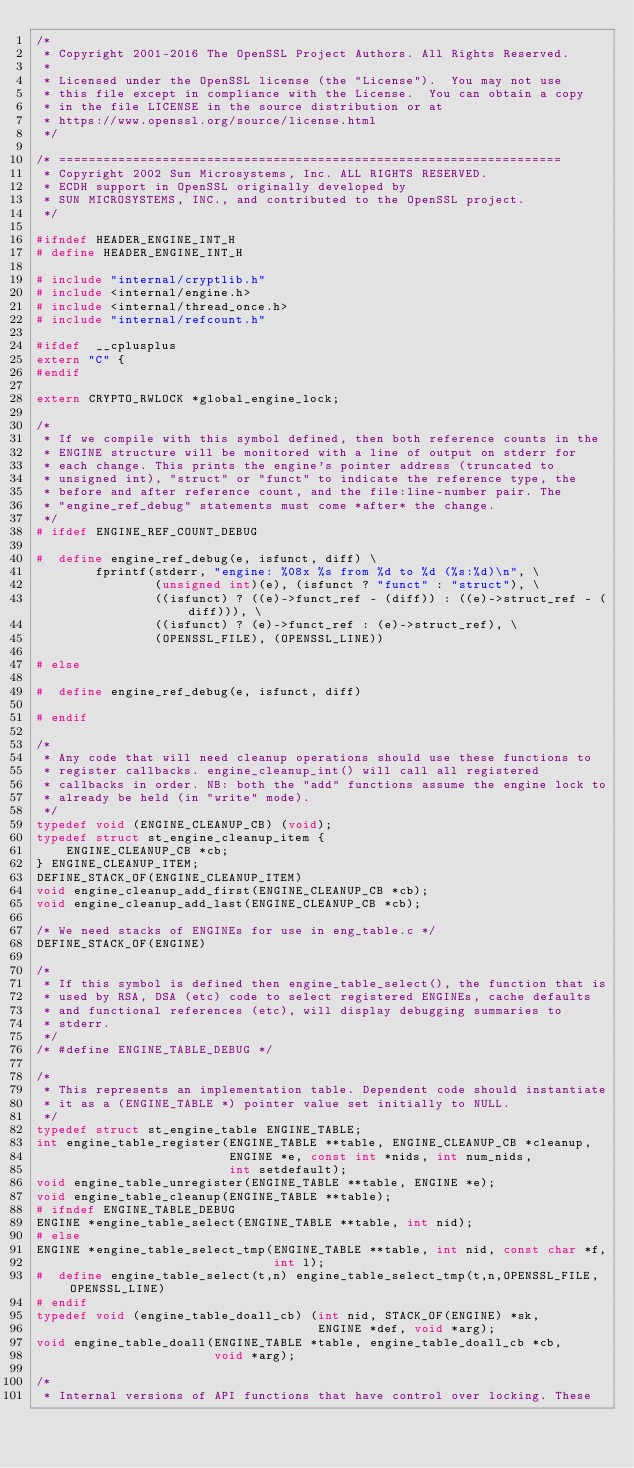<code> <loc_0><loc_0><loc_500><loc_500><_C_>/*
 * Copyright 2001-2016 The OpenSSL Project Authors. All Rights Reserved.
 *
 * Licensed under the OpenSSL license (the "License").  You may not use
 * this file except in compliance with the License.  You can obtain a copy
 * in the file LICENSE in the source distribution or at
 * https://www.openssl.org/source/license.html
 */

/* ====================================================================
 * Copyright 2002 Sun Microsystems, Inc. ALL RIGHTS RESERVED.
 * ECDH support in OpenSSL originally developed by
 * SUN MICROSYSTEMS, INC., and contributed to the OpenSSL project.
 */

#ifndef HEADER_ENGINE_INT_H
# define HEADER_ENGINE_INT_H

# include "internal/cryptlib.h"
# include <internal/engine.h>
# include <internal/thread_once.h>
# include "internal/refcount.h"

#ifdef  __cplusplus
extern "C" {
#endif

extern CRYPTO_RWLOCK *global_engine_lock;

/*
 * If we compile with this symbol defined, then both reference counts in the
 * ENGINE structure will be monitored with a line of output on stderr for
 * each change. This prints the engine's pointer address (truncated to
 * unsigned int), "struct" or "funct" to indicate the reference type, the
 * before and after reference count, and the file:line-number pair. The
 * "engine_ref_debug" statements must come *after* the change.
 */
# ifdef ENGINE_REF_COUNT_DEBUG

#  define engine_ref_debug(e, isfunct, diff) \
        fprintf(stderr, "engine: %08x %s from %d to %d (%s:%d)\n", \
                (unsigned int)(e), (isfunct ? "funct" : "struct"), \
                ((isfunct) ? ((e)->funct_ref - (diff)) : ((e)->struct_ref - (diff))), \
                ((isfunct) ? (e)->funct_ref : (e)->struct_ref), \
                (OPENSSL_FILE), (OPENSSL_LINE))

# else

#  define engine_ref_debug(e, isfunct, diff)

# endif

/*
 * Any code that will need cleanup operations should use these functions to
 * register callbacks. engine_cleanup_int() will call all registered
 * callbacks in order. NB: both the "add" functions assume the engine lock to
 * already be held (in "write" mode).
 */
typedef void (ENGINE_CLEANUP_CB) (void);
typedef struct st_engine_cleanup_item {
    ENGINE_CLEANUP_CB *cb;
} ENGINE_CLEANUP_ITEM;
DEFINE_STACK_OF(ENGINE_CLEANUP_ITEM)
void engine_cleanup_add_first(ENGINE_CLEANUP_CB *cb);
void engine_cleanup_add_last(ENGINE_CLEANUP_CB *cb);

/* We need stacks of ENGINEs for use in eng_table.c */
DEFINE_STACK_OF(ENGINE)

/*
 * If this symbol is defined then engine_table_select(), the function that is
 * used by RSA, DSA (etc) code to select registered ENGINEs, cache defaults
 * and functional references (etc), will display debugging summaries to
 * stderr.
 */
/* #define ENGINE_TABLE_DEBUG */

/*
 * This represents an implementation table. Dependent code should instantiate
 * it as a (ENGINE_TABLE *) pointer value set initially to NULL.
 */
typedef struct st_engine_table ENGINE_TABLE;
int engine_table_register(ENGINE_TABLE **table, ENGINE_CLEANUP_CB *cleanup,
                          ENGINE *e, const int *nids, int num_nids,
                          int setdefault);
void engine_table_unregister(ENGINE_TABLE **table, ENGINE *e);
void engine_table_cleanup(ENGINE_TABLE **table);
# ifndef ENGINE_TABLE_DEBUG
ENGINE *engine_table_select(ENGINE_TABLE **table, int nid);
# else
ENGINE *engine_table_select_tmp(ENGINE_TABLE **table, int nid, const char *f,
                                int l);
#  define engine_table_select(t,n) engine_table_select_tmp(t,n,OPENSSL_FILE,OPENSSL_LINE)
# endif
typedef void (engine_table_doall_cb) (int nid, STACK_OF(ENGINE) *sk,
                                      ENGINE *def, void *arg);
void engine_table_doall(ENGINE_TABLE *table, engine_table_doall_cb *cb,
                        void *arg);

/*
 * Internal versions of API functions that have control over locking. These</code> 